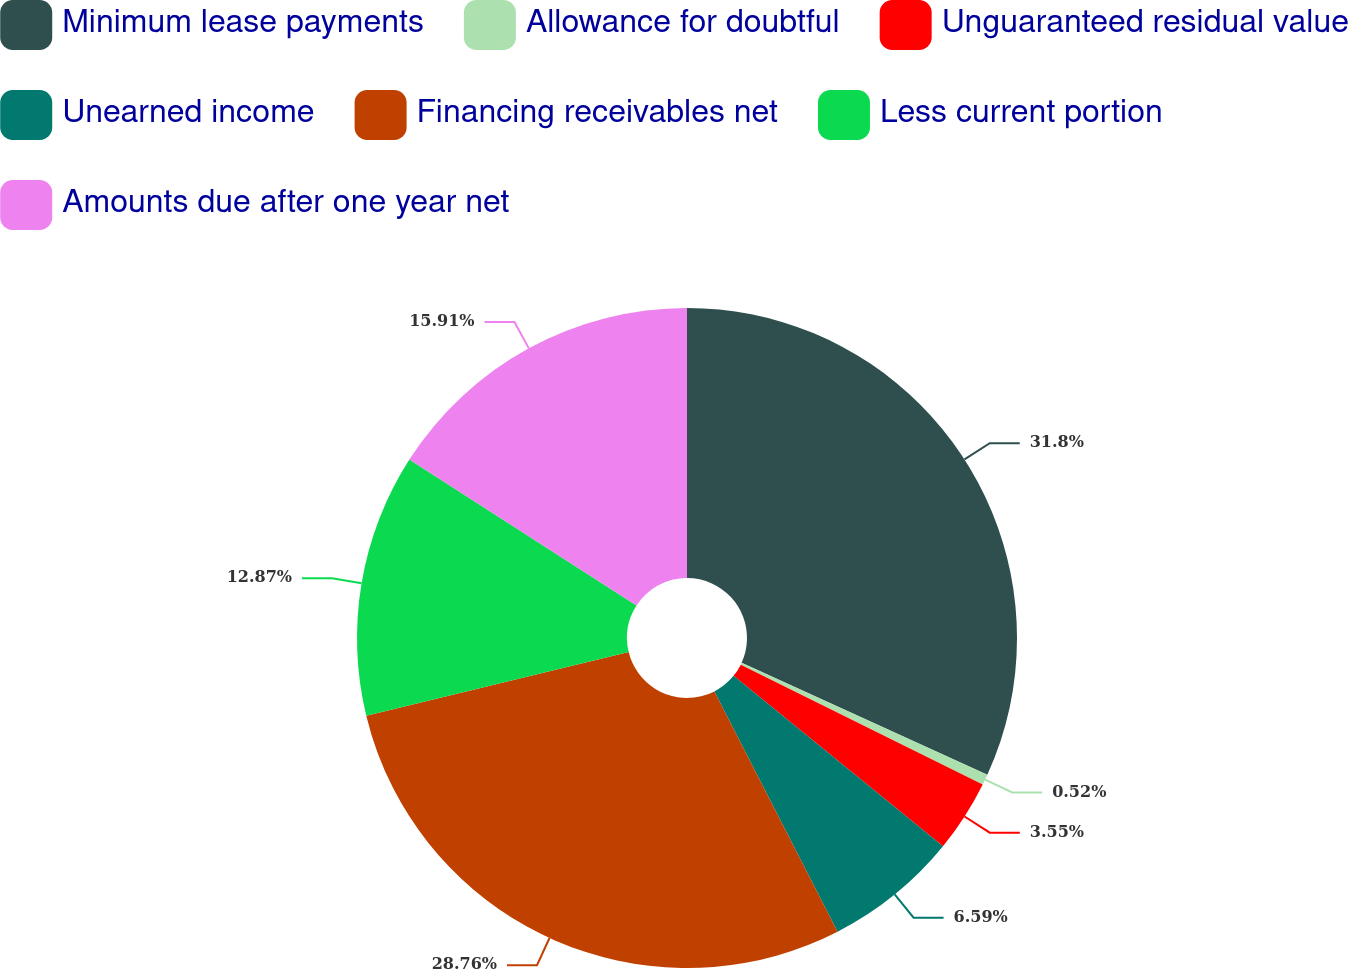Convert chart. <chart><loc_0><loc_0><loc_500><loc_500><pie_chart><fcel>Minimum lease payments<fcel>Allowance for doubtful<fcel>Unguaranteed residual value<fcel>Unearned income<fcel>Financing receivables net<fcel>Less current portion<fcel>Amounts due after one year net<nl><fcel>31.8%<fcel>0.52%<fcel>3.55%<fcel>6.59%<fcel>28.76%<fcel>12.87%<fcel>15.91%<nl></chart> 